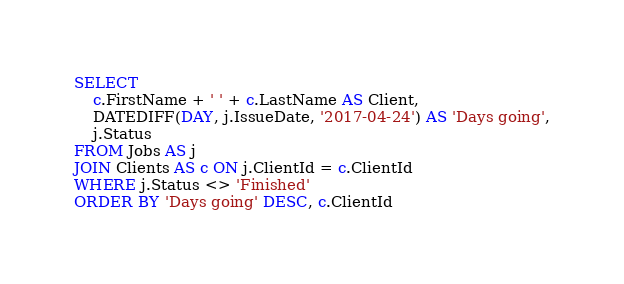Convert code to text. <code><loc_0><loc_0><loc_500><loc_500><_SQL_>SELECT 
	c.FirstName + ' ' + c.LastName AS Client,
	DATEDIFF(DAY, j.IssueDate, '2017-04-24') AS 'Days going',
	j.Status
FROM Jobs AS j
JOIN Clients AS c ON j.ClientId = c.ClientId
WHERE j.Status <> 'Finished'
ORDER BY 'Days going' DESC, c.ClientId
</code> 